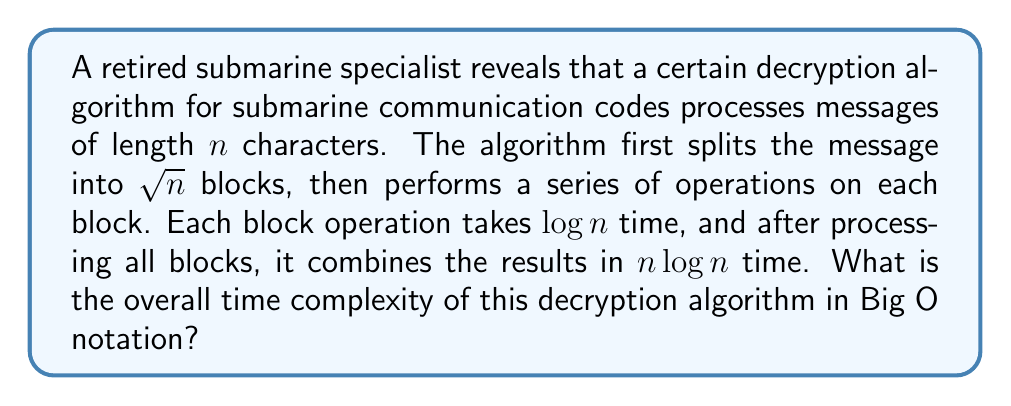Give your solution to this math problem. Let's break down the algorithm and analyze its time complexity step by step:

1) Splitting the message:
   The message of length $n$ is split into $\sqrt{n}$ blocks. This operation typically takes linear time, so it's $O(n)$.

2) Processing each block:
   - There are $\sqrt{n}$ blocks
   - Each block operation takes $\log n$ time
   - Total time for this step: $\sqrt{n} \cdot \log n$

3) Combining results:
   This step takes $n \log n$ time as given in the question.

Now, let's combine these steps:

$$T(n) = O(n) + O(\sqrt{n} \cdot \log n) + O(n \log n)$$

To determine the overall time complexity, we need to identify the dominant term:

- $O(n)$ is less than $O(n \log n)$
- $O(\sqrt{n} \cdot \log n)$ is less than $O(n \log n)$
- Therefore, $O(n \log n)$ is the dominant term

Thus, the overall time complexity of the algorithm is $O(n \log n)$.
Answer: $O(n \log n)$ 